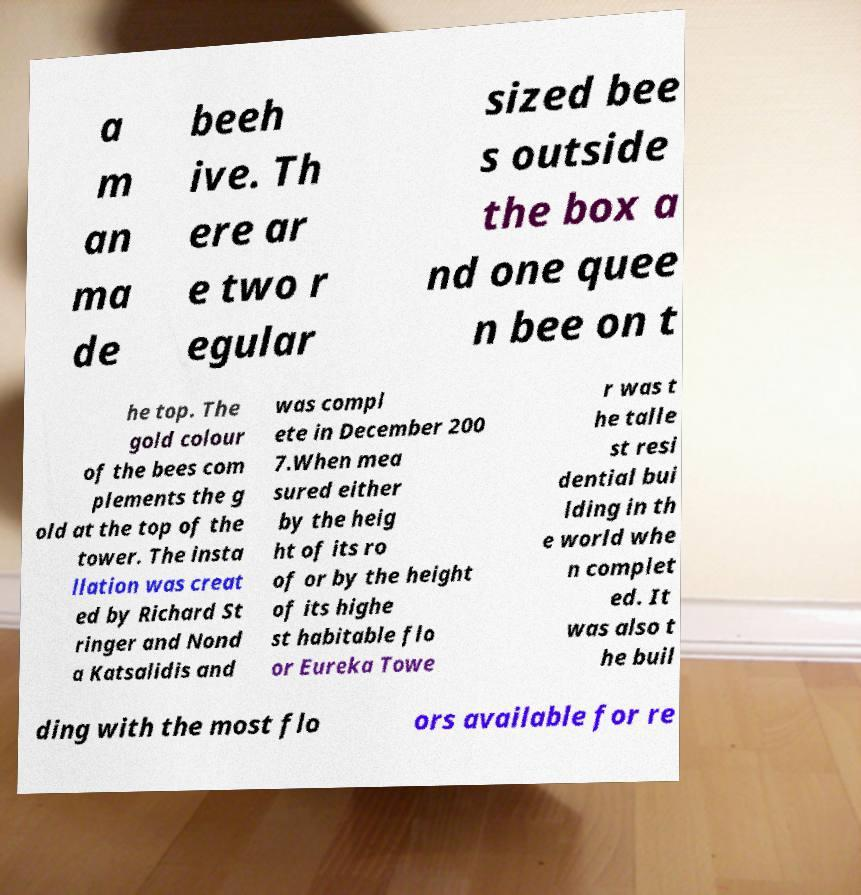What messages or text are displayed in this image? I need them in a readable, typed format. a m an ma de beeh ive. Th ere ar e two r egular sized bee s outside the box a nd one quee n bee on t he top. The gold colour of the bees com plements the g old at the top of the tower. The insta llation was creat ed by Richard St ringer and Nond a Katsalidis and was compl ete in December 200 7.When mea sured either by the heig ht of its ro of or by the height of its highe st habitable flo or Eureka Towe r was t he talle st resi dential bui lding in th e world whe n complet ed. It was also t he buil ding with the most flo ors available for re 